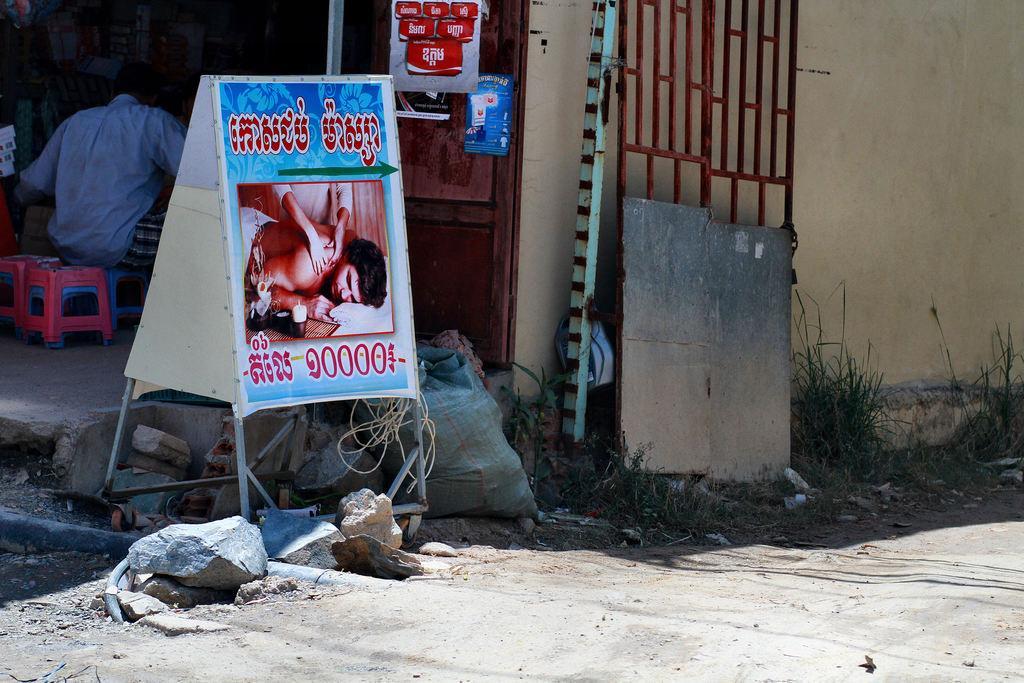Please provide a concise description of this image. In this picture we can see a board, stones, grass, and a gate and behind the gate there is a wall. Behind the board there is a man sitting on a stool and other things. 